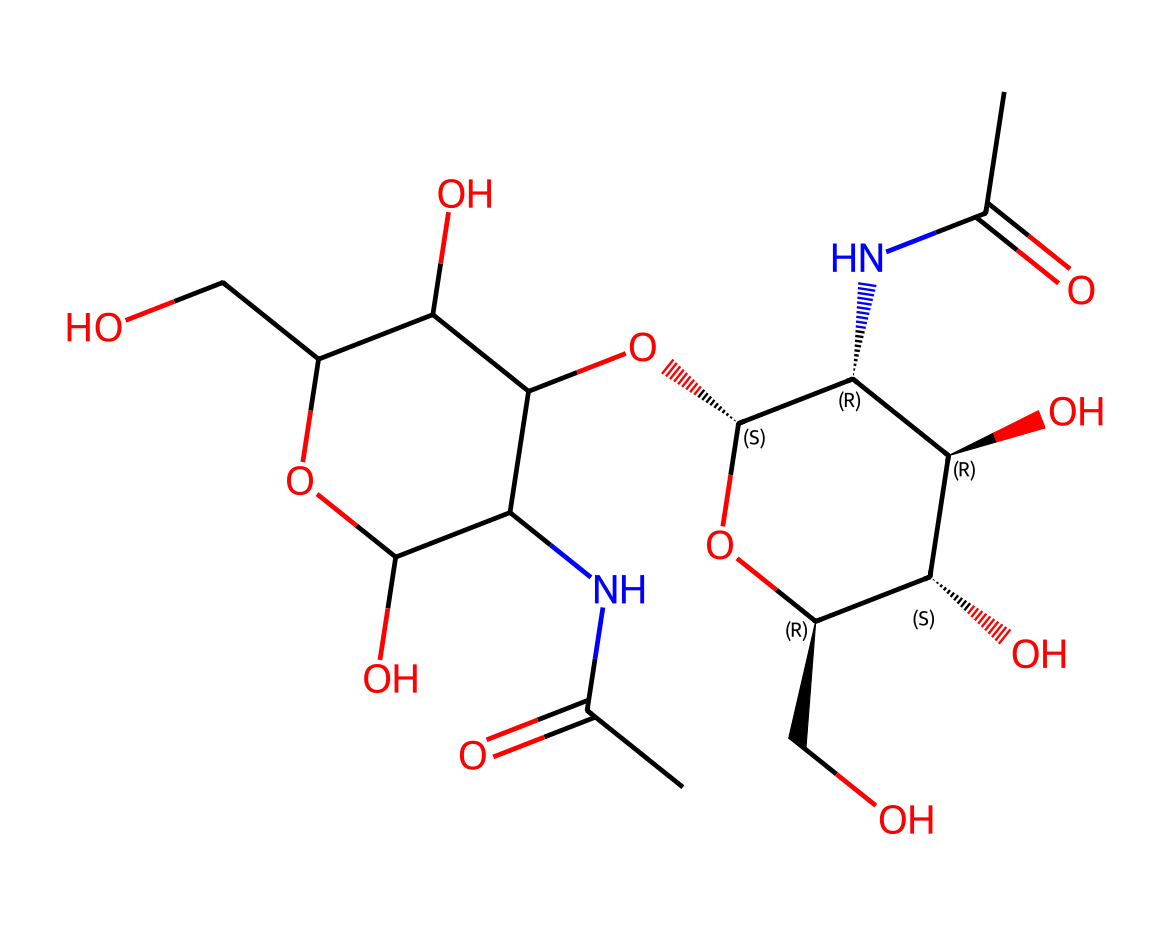how many carbon atoms are in this molecule? By analyzing the SMILES representation, each "C" corresponds to a carbon atom. Counting all instances of "C" gives a total of 14 carbon atoms in this molecule.
Answer: 14 what functional groups are present in this structure? The SMILES includes segments that represent amides (NC(=O)), hydroxyl (-OH), and ether groups (O). Thus, the molecule exhibits multiple functional groups including amide and hydroxyl.
Answer: amide, hydroxyl, ether what is the molecular weight of hyaluronic acid based on this structure? To calculate the molecular weight, we sum the weights of all atoms in the structure. Each carbon (C) weighs approximately 12.01 g/mol, oxygen (O) 16.00 g/mol, and nitrogen (N) 14.01 g/mol. Performing the calculation leads us to a molecular weight close to 403.35 g/mol.
Answer: 403.35 g/mol what role do the hydroxyl groups play in this molecule? Hydroxyl groups (-OH) contribute to the hydrophilicity of the molecule, promoting its ability to attract and retain water, which is essential for moisturizing properties in cosmetic formulations.
Answer: hydrophilicity how does the molecular arrangement of hyaluronic acid affect its biological function? The molecular arrangement, particularly the presence of multiple hydroxyl groups and the ability to form hydrogen bonds, allows hyaluronic acid to retain moisture and maintain skin elasticity, which is crucial in its role as a hydrating agent in cosmetics.
Answer: moisture retention, skin elasticity 